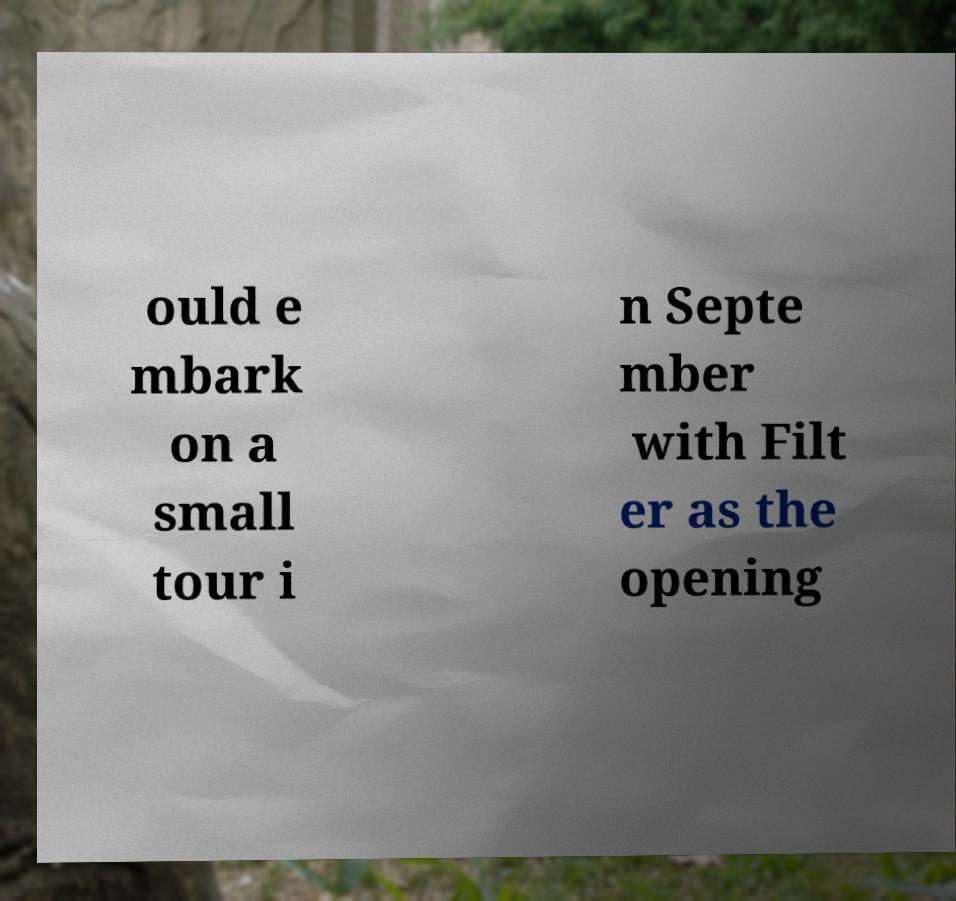I need the written content from this picture converted into text. Can you do that? ould e mbark on a small tour i n Septe mber with Filt er as the opening 